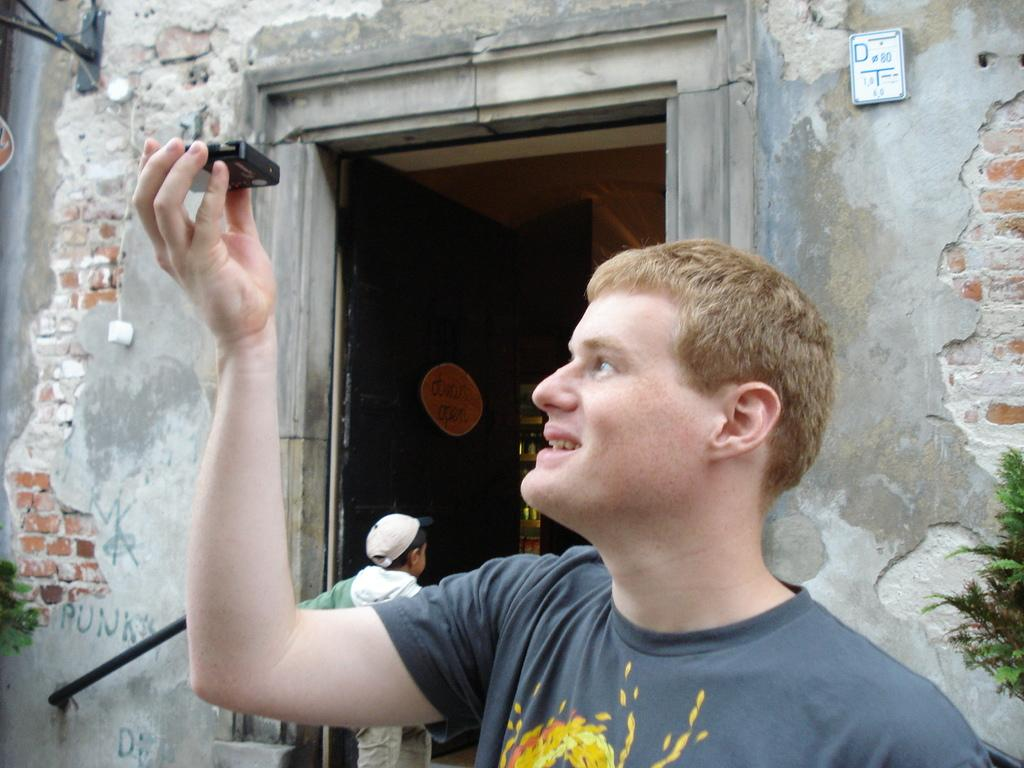What is the main subject of the image? There is a person standing in the middle of the image. What is the person holding in his hand? The person is holding something in his hand, but the specific object is not mentioned in the facts. What is located behind the person? There is a wall behind the person, and plants are visible behind him. Are there any other people in the image? Yes, there is a kid standing near the plants. What type of debt is the person discussing with the kid in the image? There is no mention of debt or any discussion in the image. The image only shows a person standing with something in his hand, a wall and plants behind him, and a kid standing near the plants. 